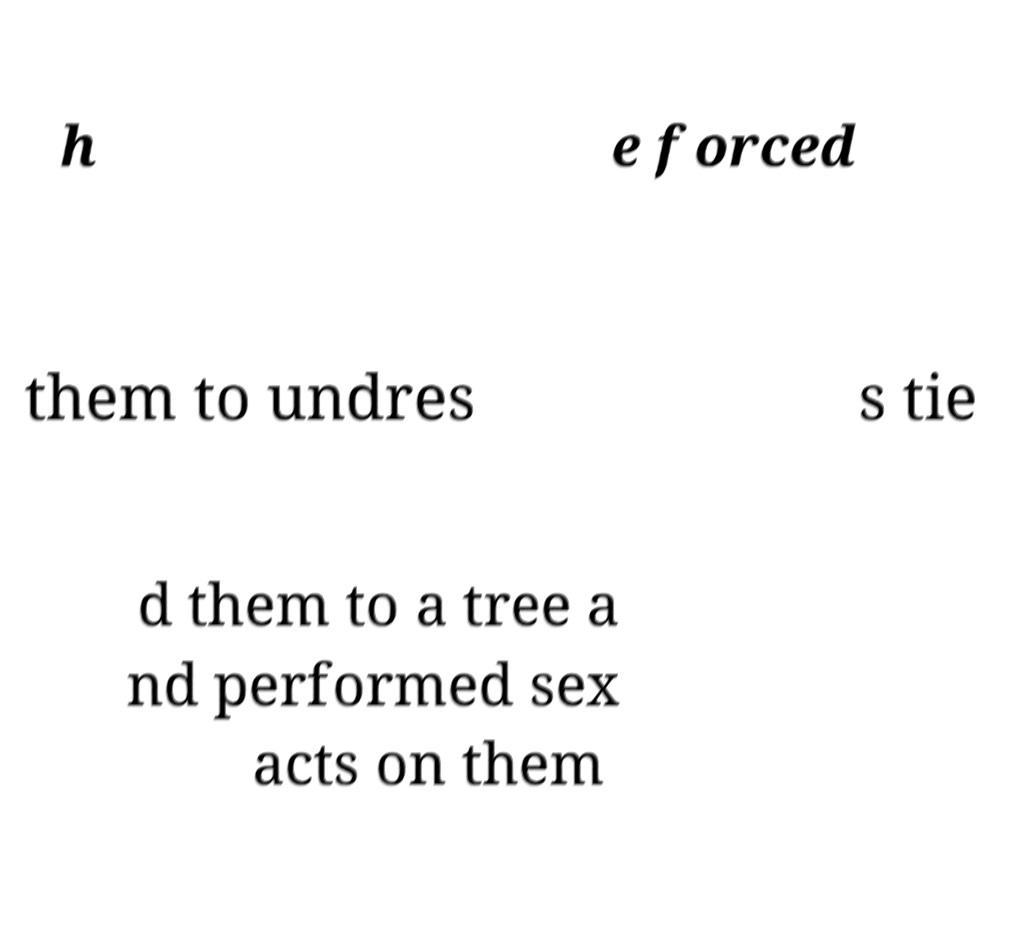Please read and relay the text visible in this image. What does it say? h e forced them to undres s tie d them to a tree a nd performed sex acts on them 